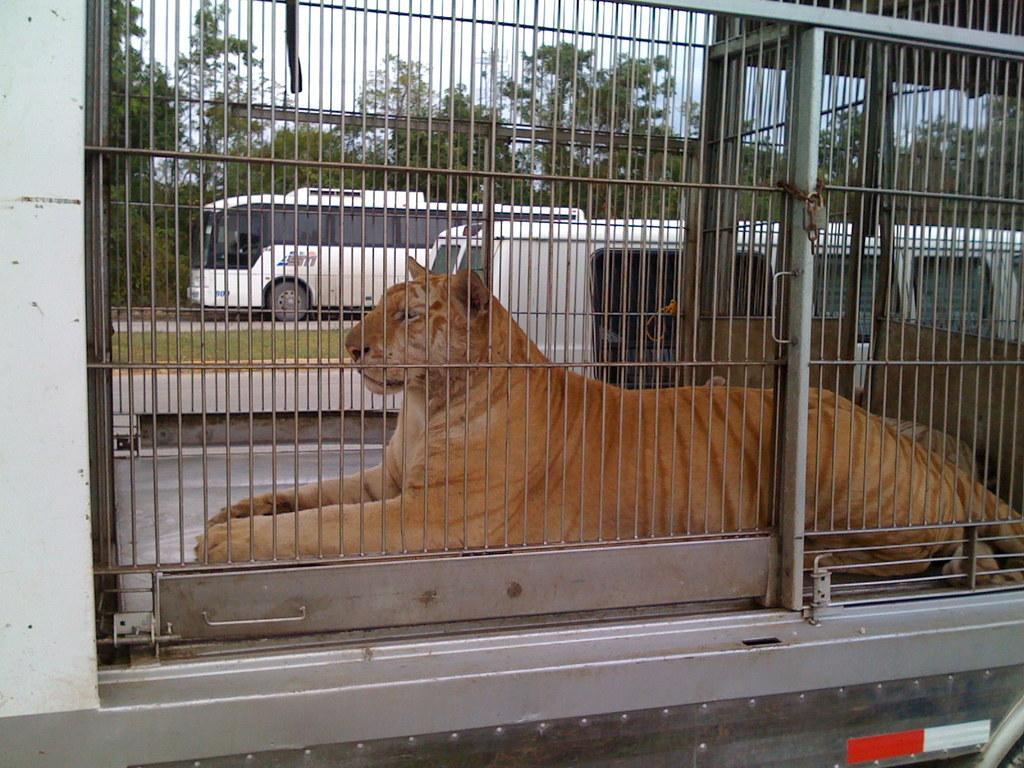Describe this image in one or two sentences. In this image there is a tiger sitting inside a cage. Behind it there are vehicles on the road. In the center of the road there's grass on the ground. In the background there are trees. At the top there is the sky. There are chains and a lock to the cage. 